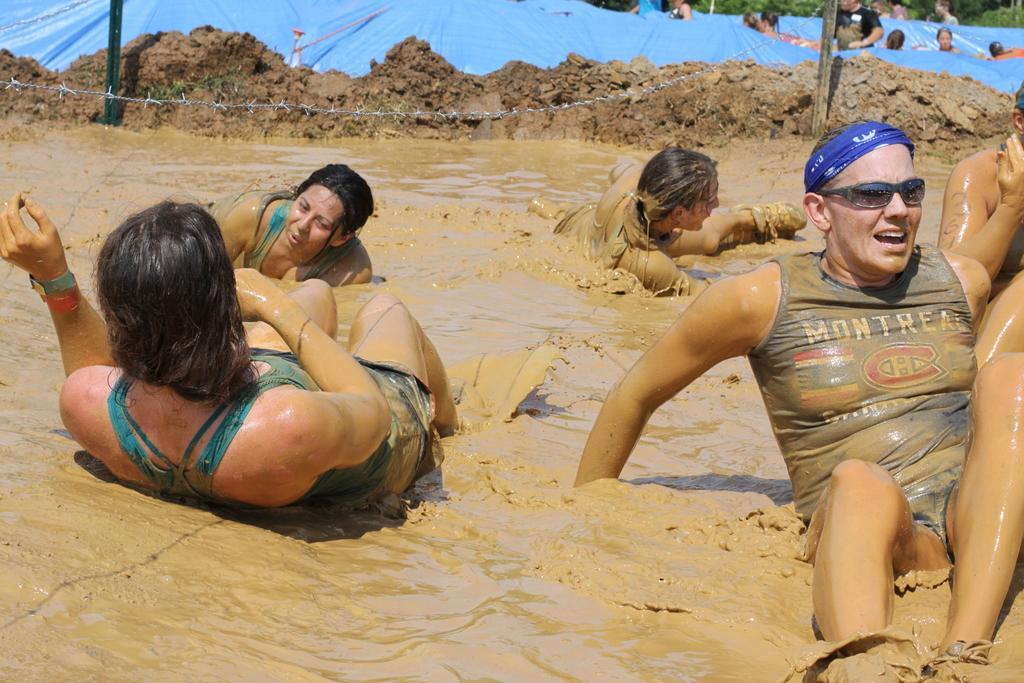In one or two sentences, can you explain what this image depicts? In this image, we can see the mud, there are some people on the mud. 